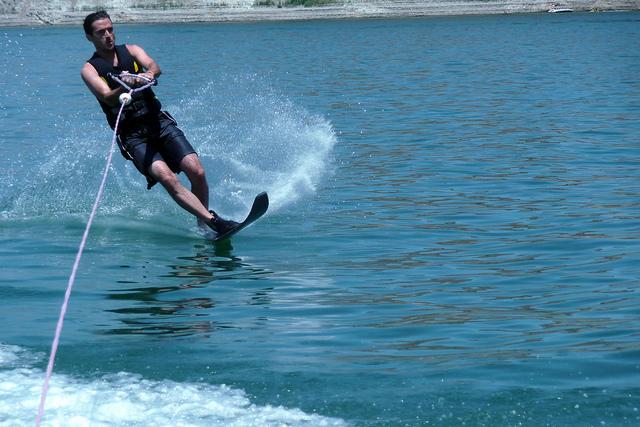How long this man has been surfing on the water?
Short answer required. 10 minutes. Are there waves?
Be succinct. No. What is the man on?
Be succinct. Water ski. What are the water skiers doing in the water?
Answer briefly. Skiing. What is the man doing?
Short answer required. Water skiing. What sport is this?
Keep it brief. Water skiing. 